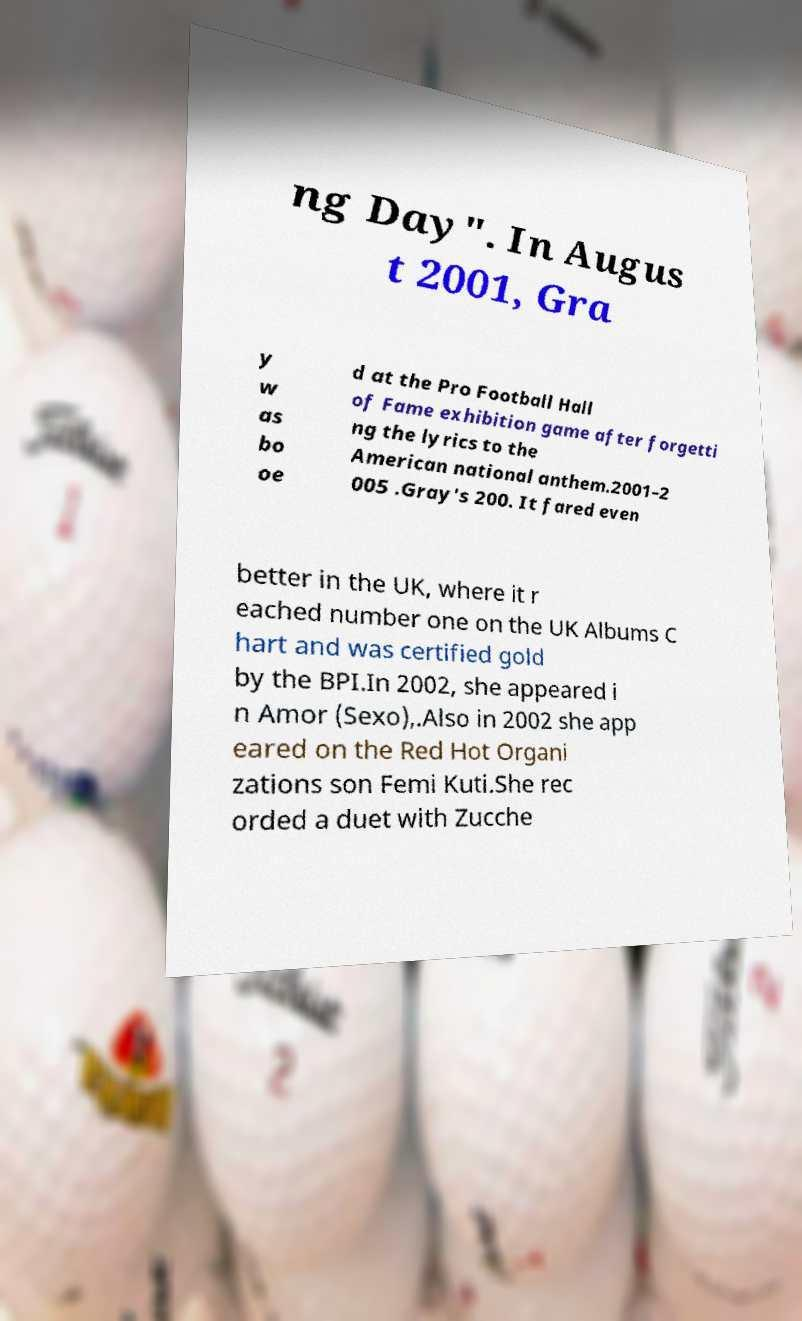Can you read and provide the text displayed in the image?This photo seems to have some interesting text. Can you extract and type it out for me? ng Day". In Augus t 2001, Gra y w as bo oe d at the Pro Football Hall of Fame exhibition game after forgetti ng the lyrics to the American national anthem.2001–2 005 .Gray's 200. It fared even better in the UK, where it r eached number one on the UK Albums C hart and was certified gold by the BPI.In 2002, she appeared i n Amor (Sexo),.Also in 2002 she app eared on the Red Hot Organi zations son Femi Kuti.She rec orded a duet with Zucche 